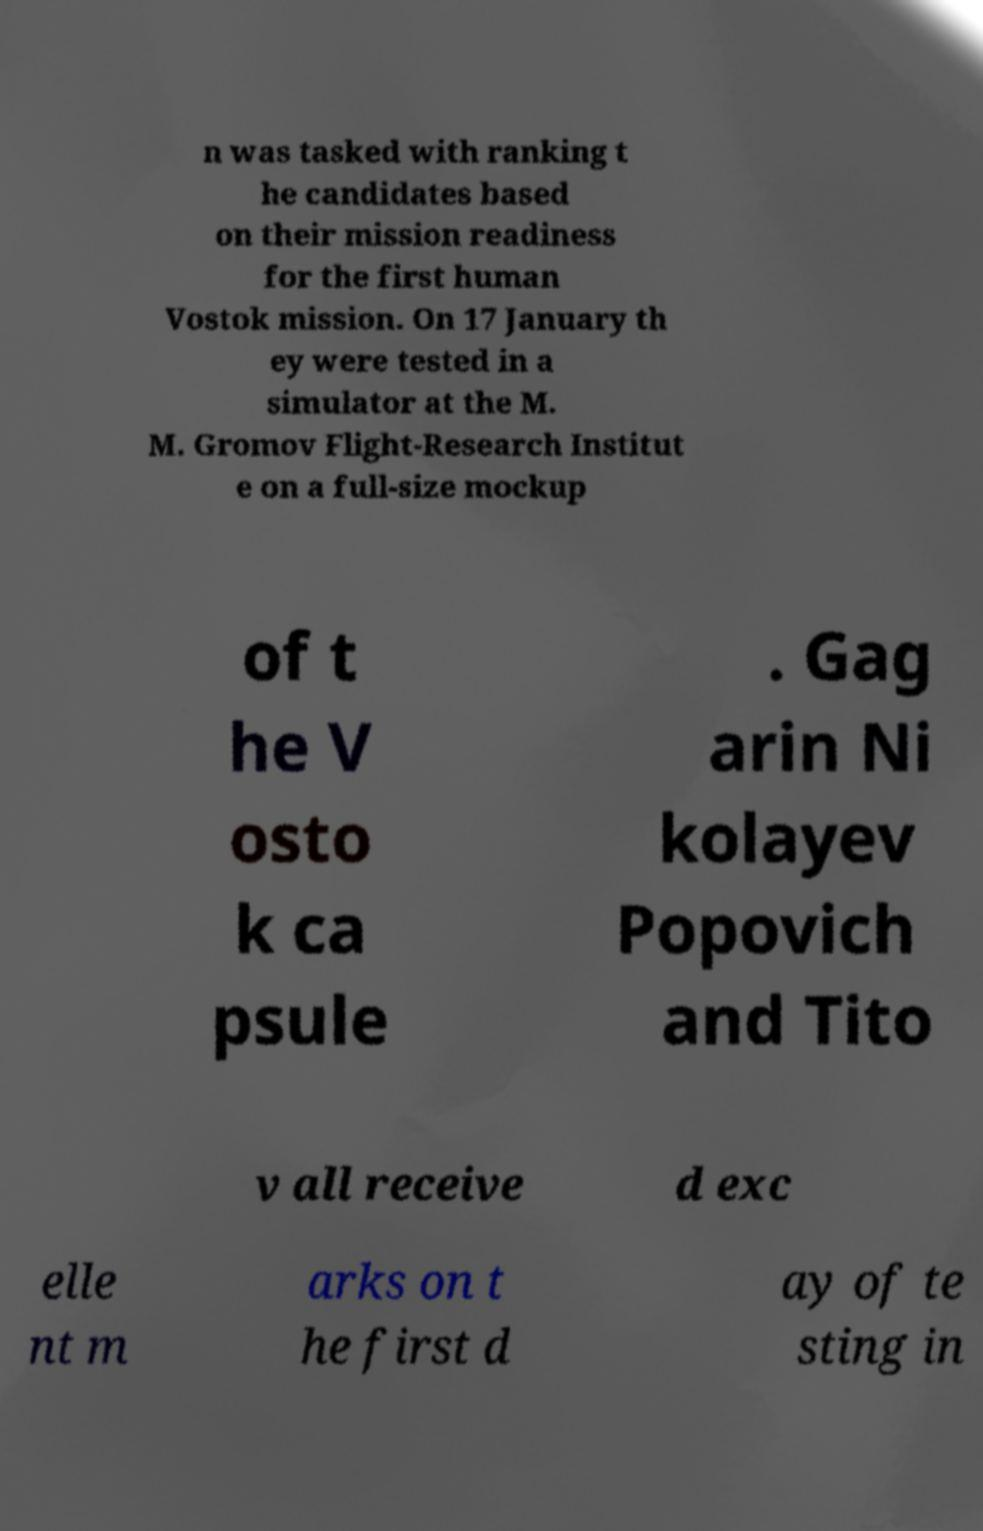There's text embedded in this image that I need extracted. Can you transcribe it verbatim? n was tasked with ranking t he candidates based on their mission readiness for the first human Vostok mission. On 17 January th ey were tested in a simulator at the M. M. Gromov Flight-Research Institut e on a full-size mockup of t he V osto k ca psule . Gag arin Ni kolayev Popovich and Tito v all receive d exc elle nt m arks on t he first d ay of te sting in 